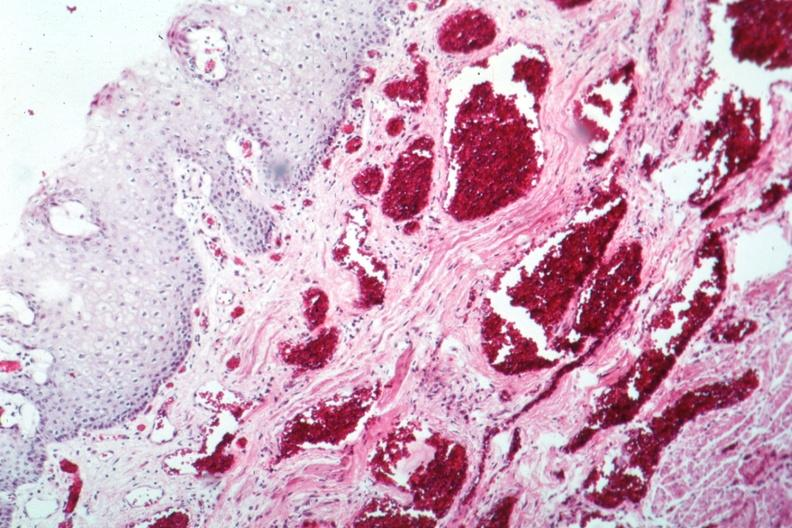s gastrointestinal present?
Answer the question using a single word or phrase. Yes 